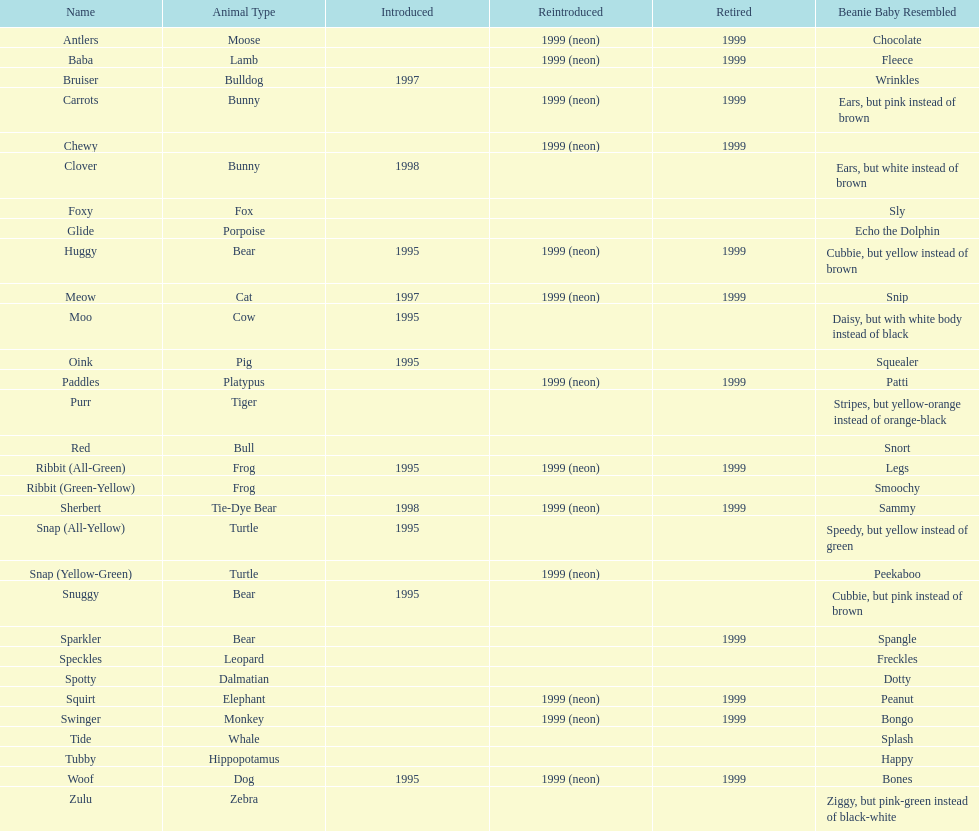In 1999, how many pillow pals were brought back to the market? 13. 